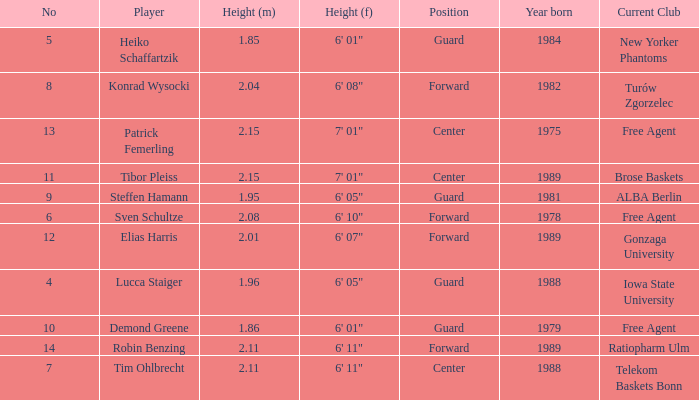Name the height for steffen hamann 6' 05". 